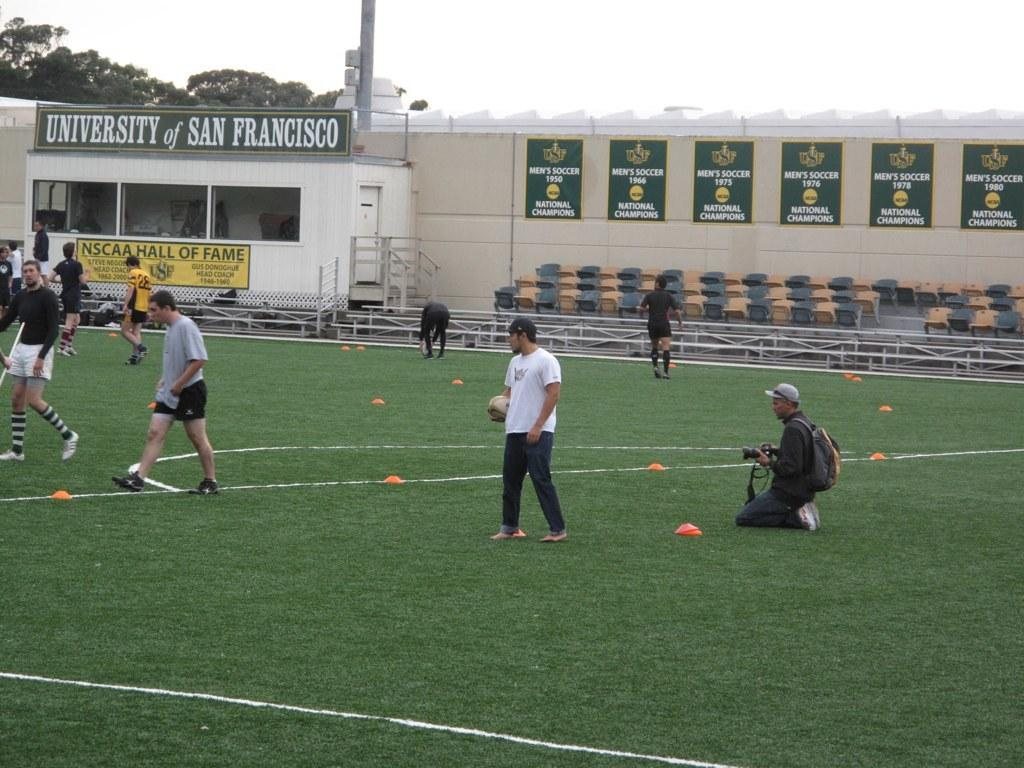<image>
Render a clear and concise summary of the photo. At the University of San Francisco a group of players practice on the soccer field. 